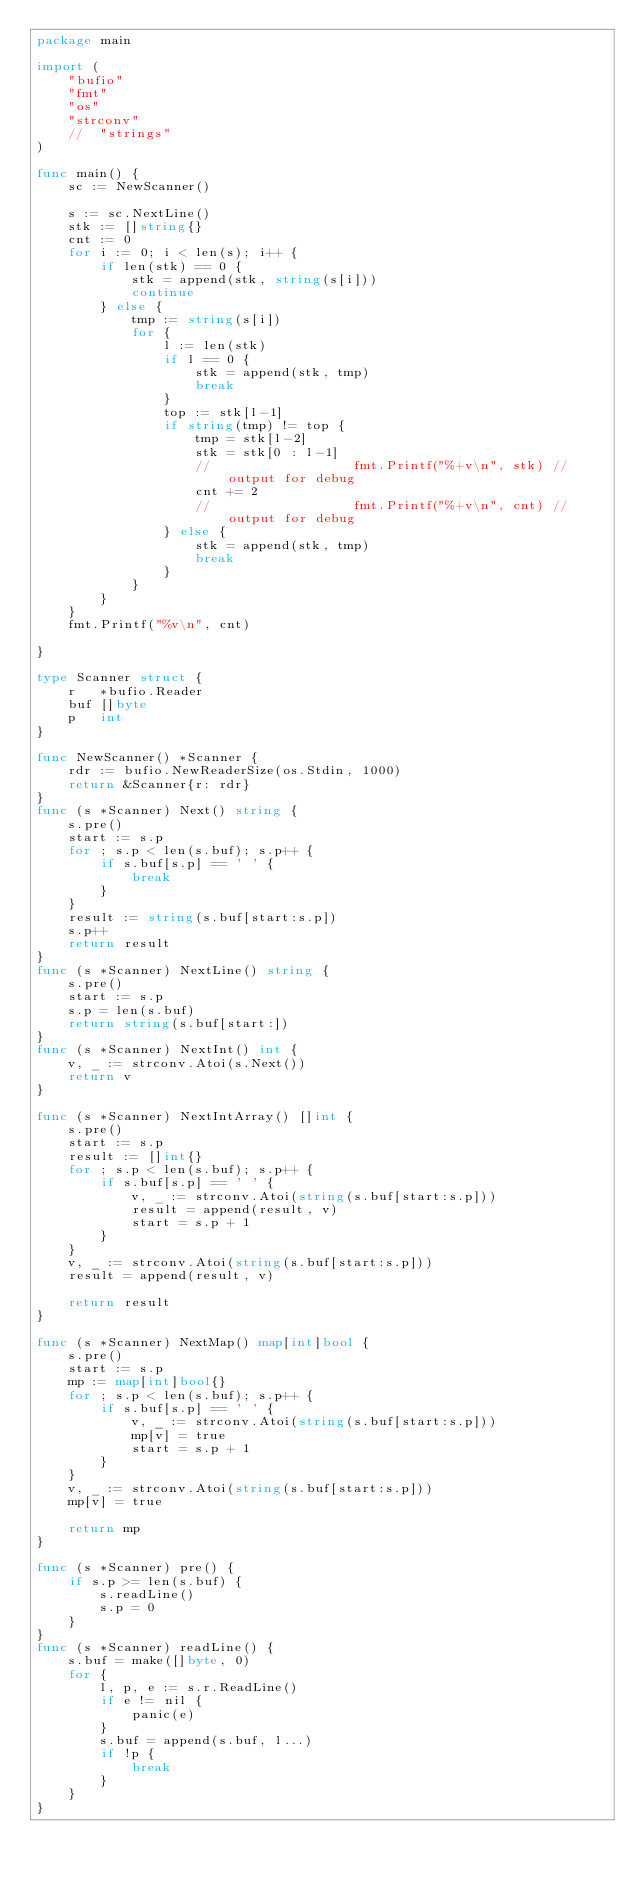Convert code to text. <code><loc_0><loc_0><loc_500><loc_500><_Go_>package main

import (
	"bufio"
	"fmt"
	"os"
	"strconv"
	//	"strings"
)

func main() {
	sc := NewScanner()

	s := sc.NextLine()
	stk := []string{}
	cnt := 0
	for i := 0; i < len(s); i++ {
		if len(stk) == 0 {
			stk = append(stk, string(s[i]))
			continue
		} else {
			tmp := string(s[i])
			for {
				l := len(stk)
				if l == 0 {
					stk = append(stk, tmp)
					break
				}
				top := stk[l-1]
				if string(tmp) != top {
					tmp = stk[l-2]
					stk = stk[0 : l-1]
					//					fmt.Printf("%+v\n", stk) // output for debug
					cnt += 2
					//					fmt.Printf("%+v\n", cnt) // output for debug
				} else {
					stk = append(stk, tmp)
					break
				}
			}
		}
	}
	fmt.Printf("%v\n", cnt)

}

type Scanner struct {
	r   *bufio.Reader
	buf []byte
	p   int
}

func NewScanner() *Scanner {
	rdr := bufio.NewReaderSize(os.Stdin, 1000)
	return &Scanner{r: rdr}
}
func (s *Scanner) Next() string {
	s.pre()
	start := s.p
	for ; s.p < len(s.buf); s.p++ {
		if s.buf[s.p] == ' ' {
			break
		}
	}
	result := string(s.buf[start:s.p])
	s.p++
	return result
}
func (s *Scanner) NextLine() string {
	s.pre()
	start := s.p
	s.p = len(s.buf)
	return string(s.buf[start:])
}
func (s *Scanner) NextInt() int {
	v, _ := strconv.Atoi(s.Next())
	return v
}

func (s *Scanner) NextIntArray() []int {
	s.pre()
	start := s.p
	result := []int{}
	for ; s.p < len(s.buf); s.p++ {
		if s.buf[s.p] == ' ' {
			v, _ := strconv.Atoi(string(s.buf[start:s.p]))
			result = append(result, v)
			start = s.p + 1
		}
	}
	v, _ := strconv.Atoi(string(s.buf[start:s.p]))
	result = append(result, v)

	return result
}

func (s *Scanner) NextMap() map[int]bool {
	s.pre()
	start := s.p
	mp := map[int]bool{}
	for ; s.p < len(s.buf); s.p++ {
		if s.buf[s.p] == ' ' {
			v, _ := strconv.Atoi(string(s.buf[start:s.p]))
			mp[v] = true
			start = s.p + 1
		}
	}
	v, _ := strconv.Atoi(string(s.buf[start:s.p]))
	mp[v] = true

	return mp
}

func (s *Scanner) pre() {
	if s.p >= len(s.buf) {
		s.readLine()
		s.p = 0
	}
}
func (s *Scanner) readLine() {
	s.buf = make([]byte, 0)
	for {
		l, p, e := s.r.ReadLine()
		if e != nil {
			panic(e)
		}
		s.buf = append(s.buf, l...)
		if !p {
			break
		}
	}
}
</code> 